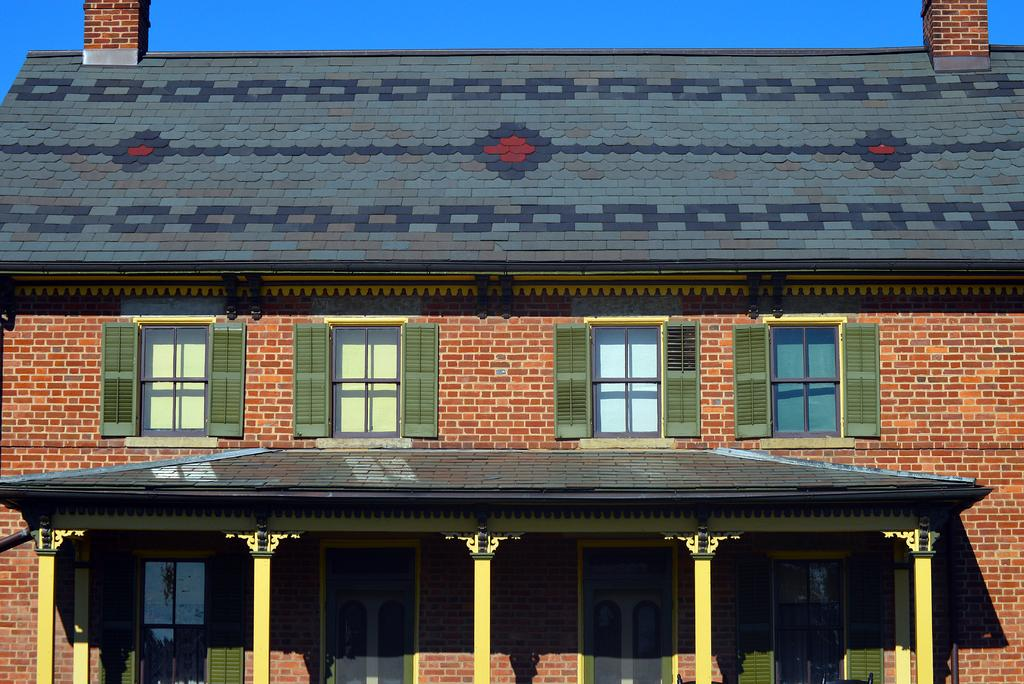What type of structure is in the picture? There is a house in the picture. How many windows are on the house? The house has four windows. How many doors are on the house? The house has four doors. What material is the house made of? The house is made of bricks. What can be seen in the background of the picture? The sky is visible in the background of the picture. What type of vest is hanging on the door of the house in the image? There is no vest present in the image; the house has four doors, but no vests are visible. 